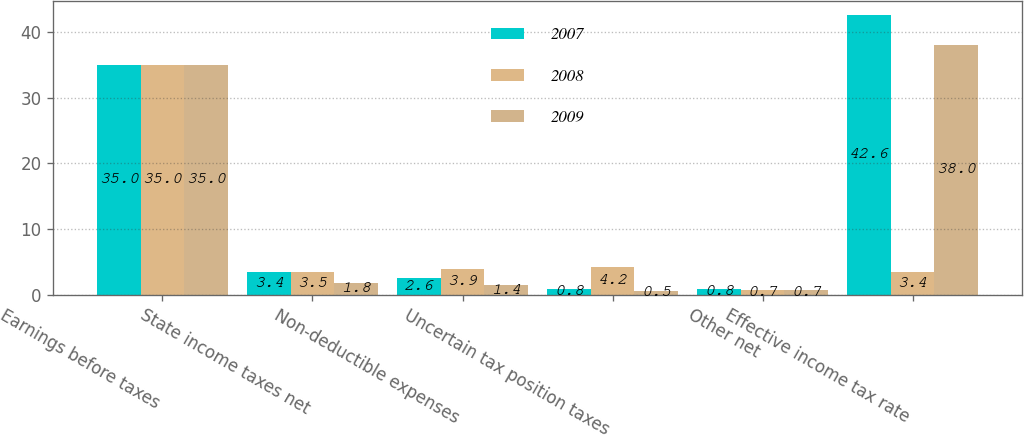Convert chart. <chart><loc_0><loc_0><loc_500><loc_500><stacked_bar_chart><ecel><fcel>Earnings before taxes<fcel>State income taxes net<fcel>Non-deductible expenses<fcel>Uncertain tax position taxes<fcel>Other net<fcel>Effective income tax rate<nl><fcel>2007<fcel>35<fcel>3.4<fcel>2.6<fcel>0.8<fcel>0.8<fcel>42.6<nl><fcel>2008<fcel>35<fcel>3.5<fcel>3.9<fcel>4.2<fcel>0.7<fcel>3.4<nl><fcel>2009<fcel>35<fcel>1.8<fcel>1.4<fcel>0.5<fcel>0.7<fcel>38<nl></chart> 